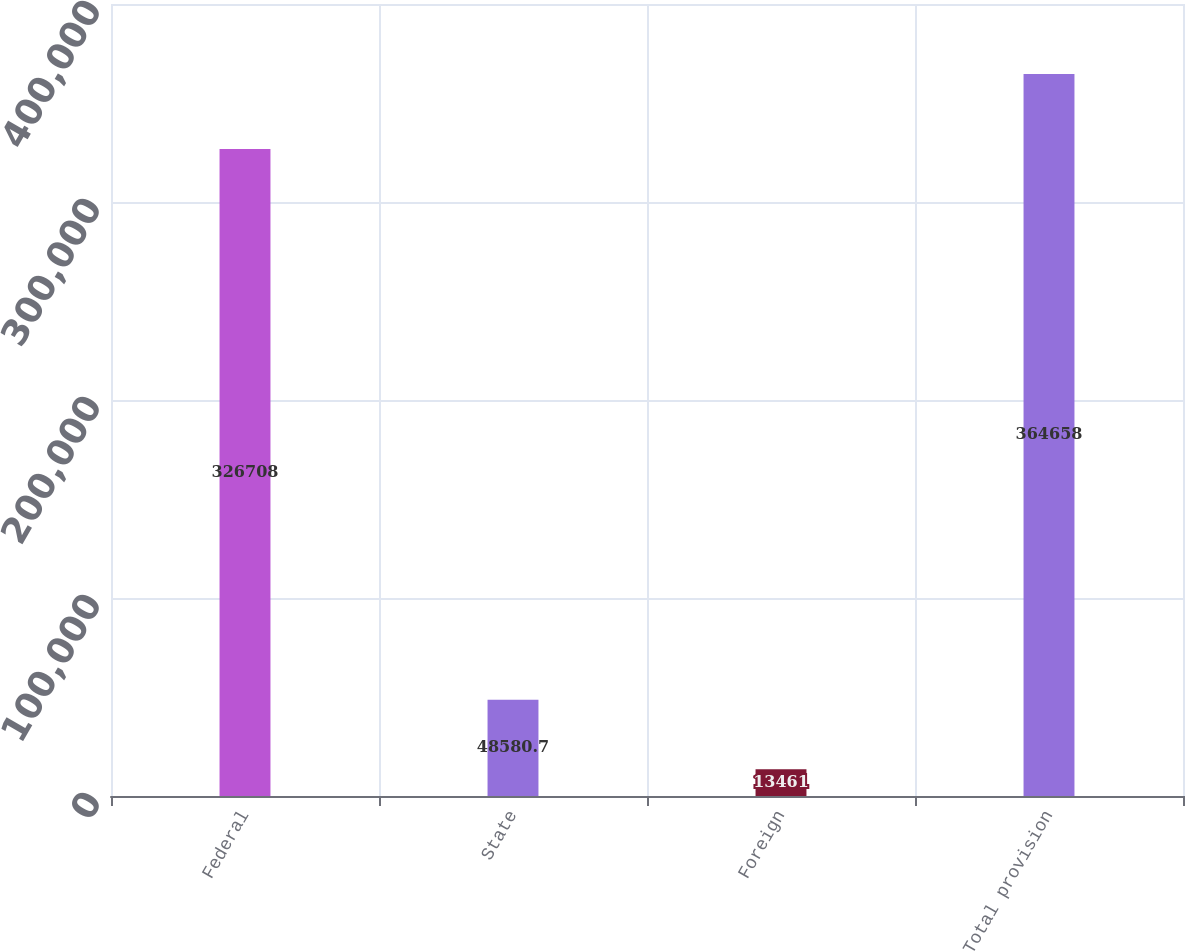Convert chart. <chart><loc_0><loc_0><loc_500><loc_500><bar_chart><fcel>Federal<fcel>State<fcel>Foreign<fcel>Total provision<nl><fcel>326708<fcel>48580.7<fcel>13461<fcel>364658<nl></chart> 